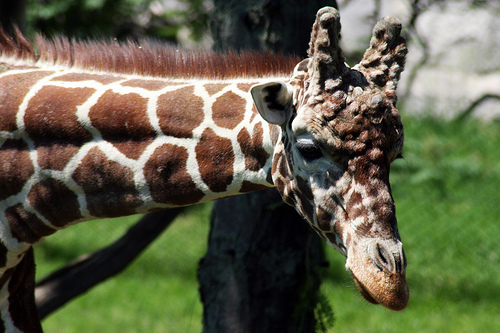<image>
Can you confirm if the giraffe is behind the tree? No. The giraffe is not behind the tree. From this viewpoint, the giraffe appears to be positioned elsewhere in the scene. Where is the monkey in relation to the gate? Is it in front of the gate? No. The monkey is not in front of the gate. The spatial positioning shows a different relationship between these objects. 